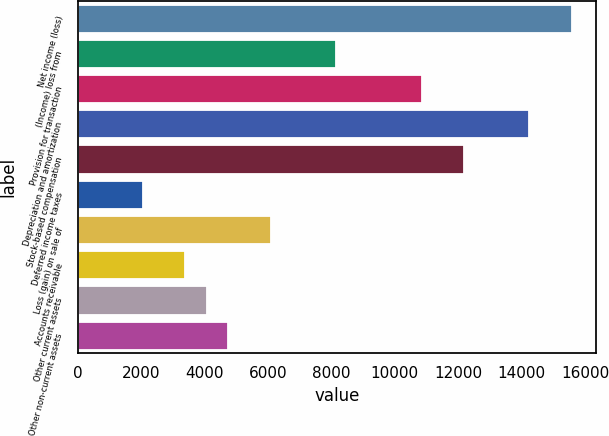Convert chart to OTSL. <chart><loc_0><loc_0><loc_500><loc_500><bar_chart><fcel>Net income (loss)<fcel>(Income) loss from<fcel>Provision for transaction<fcel>Depreciation and amortization<fcel>Stock-based compensation<fcel>Deferred income taxes<fcel>Loss (gain) on sale of<fcel>Accounts receivable<fcel>Other current assets<fcel>Other non-current assets<nl><fcel>15584.6<fcel>8135.4<fcel>10844.2<fcel>14230.2<fcel>12198.6<fcel>2040.6<fcel>6103.8<fcel>3395<fcel>4072.2<fcel>4749.4<nl></chart> 